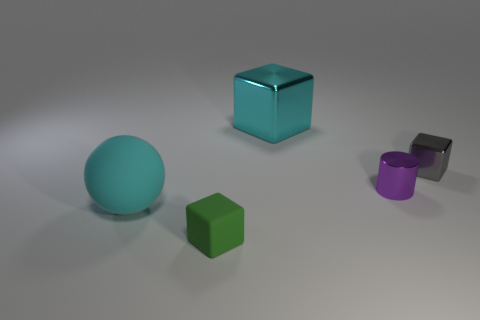What number of brown things are either spheres or cylinders?
Your answer should be compact. 0. Are there an equal number of cyan blocks that are on the left side of the gray shiny cube and cubes?
Provide a short and direct response. No. What number of objects are either purple metal cylinders or things behind the green object?
Ensure brevity in your answer.  4. Is the big cube the same color as the small cylinder?
Your answer should be very brief. No. Are there any large blue objects made of the same material as the green object?
Keep it short and to the point. No. There is another shiny object that is the same shape as the gray object; what is its color?
Offer a terse response. Cyan. Is the big cyan cube made of the same material as the block in front of the big cyan sphere?
Provide a succinct answer. No. There is a large thing that is in front of the shiny cube that is to the right of the cyan metal thing; what shape is it?
Your answer should be very brief. Sphere. Does the object that is behind the gray metallic object have the same size as the small metallic cylinder?
Make the answer very short. No. How many other objects are the same shape as the big cyan metal object?
Give a very brief answer. 2. 